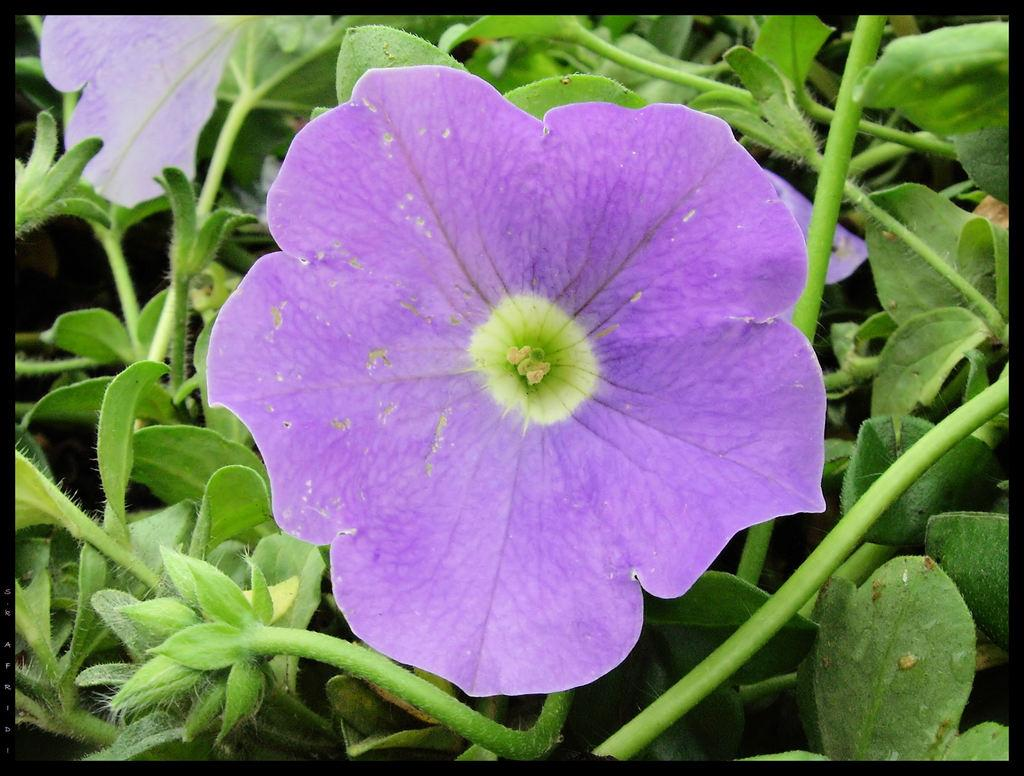What is present in the image? There is a plant in the image. How many flowers does the plant have? The plant has two flowers. What is the color of the flowers? The flowers are in violet color. What is the color of the leaves and stems of the plant? The leaves and stems of the plant are in green color. Can the plant in the image fly? No, the plant in the image cannot fly, as plants do not have the ability to fly. 